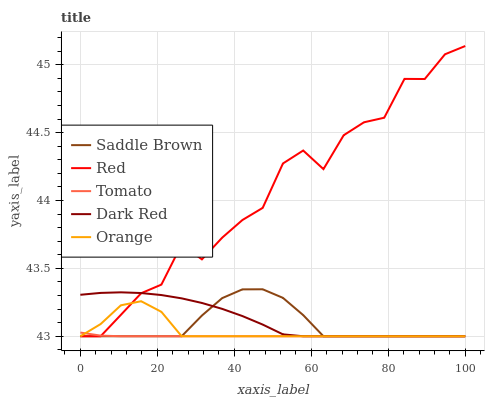Does Tomato have the minimum area under the curve?
Answer yes or no. Yes. Does Red have the maximum area under the curve?
Answer yes or no. Yes. Does Dark Red have the minimum area under the curve?
Answer yes or no. No. Does Dark Red have the maximum area under the curve?
Answer yes or no. No. Is Tomato the smoothest?
Answer yes or no. Yes. Is Red the roughest?
Answer yes or no. Yes. Is Dark Red the smoothest?
Answer yes or no. No. Is Dark Red the roughest?
Answer yes or no. No. Does Tomato have the lowest value?
Answer yes or no. Yes. Does Red have the highest value?
Answer yes or no. Yes. Does Dark Red have the highest value?
Answer yes or no. No. Does Dark Red intersect Saddle Brown?
Answer yes or no. Yes. Is Dark Red less than Saddle Brown?
Answer yes or no. No. Is Dark Red greater than Saddle Brown?
Answer yes or no. No. 